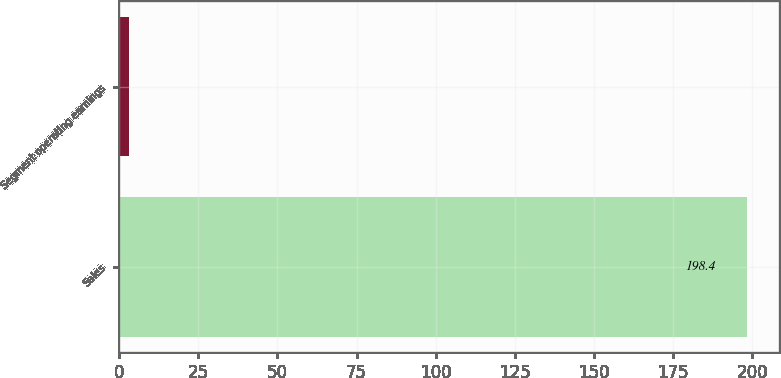<chart> <loc_0><loc_0><loc_500><loc_500><bar_chart><fcel>Sales<fcel>Segment operating earnings<nl><fcel>198.4<fcel>3<nl></chart> 